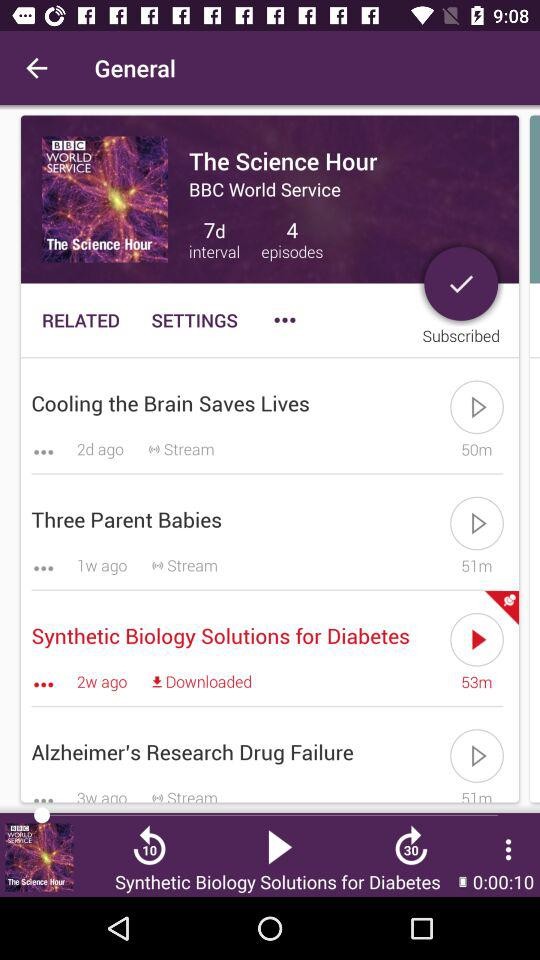What is the time duration of the "Three Parent Babies" episode? The time duration is 51 minutes. 